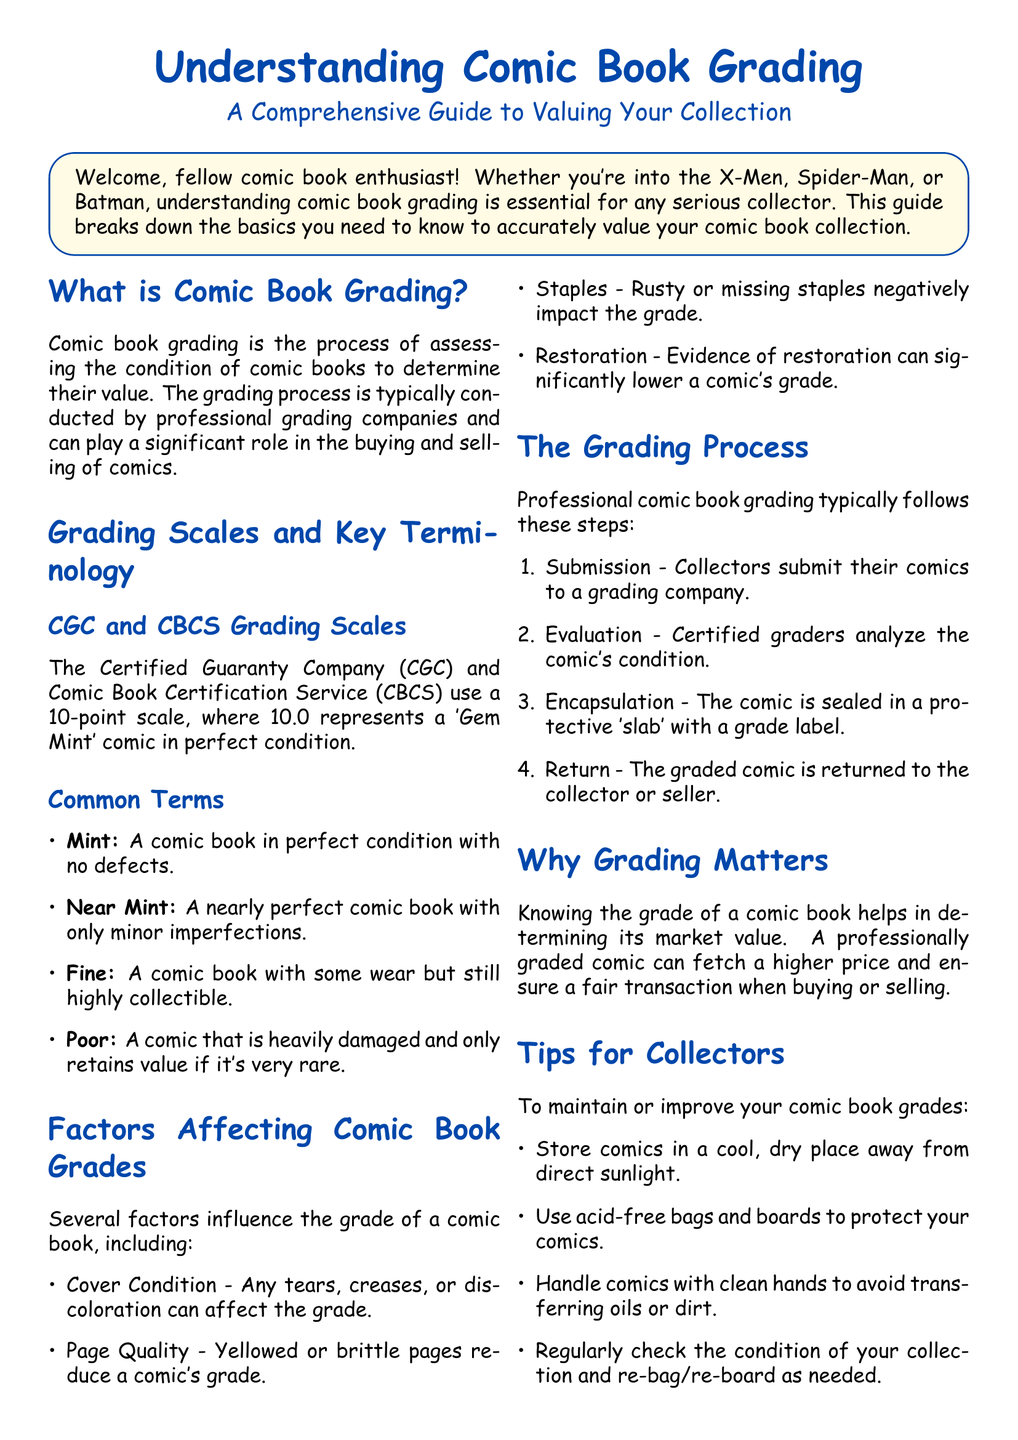What is comic book grading? Comic book grading is the process of assessing the condition of comic books to determine their value.
Answer: Assessing condition What does a grade of 10.0 represent? A grade of 10.0 represents a 'Gem Mint' comic in perfect condition.
Answer: Gem Mint What are the two main grading companies mentioned? The two main grading companies mentioned are the Certified Guaranty Company (CGC) and Comic Book Certification Service (CBCS).
Answer: CGC and CBCS What is the term for a comic that is heavily damaged? The term for a comic that is heavily damaged is 'Poor.'
Answer: Poor What factor can negatively impact a comic's grade related to its pages? The factor that can negatively impact a comic's grade related to its pages is yellowed or brittle pages.
Answer: Yellowed or brittle pages How many steps are in the professional grading process? There are four steps in the professional grading process.
Answer: Four steps Why is knowing the grade of a comic book important? Knowing the grade of a comic book helps in determining its market value.
Answer: Market value What should collectors use to protect their comics? Collectors should use acid-free bags and boards to protect their comics.
Answer: Acid-free bags and boards What action should be taken regularly to maintain comic book condition? Collectors should regularly check the condition of their collection and re-bag/re-board as needed.
Answer: Re-bag/re-board 